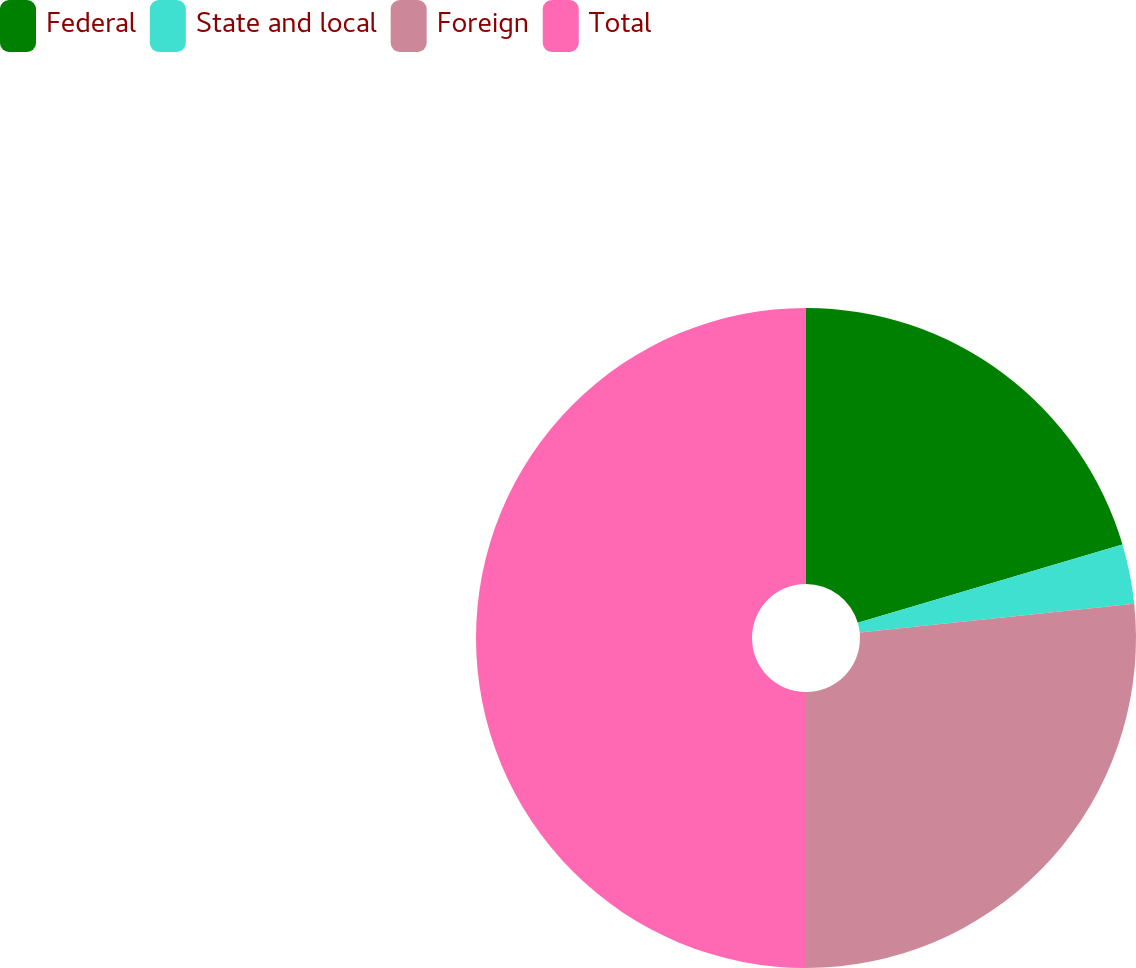<chart> <loc_0><loc_0><loc_500><loc_500><pie_chart><fcel>Federal<fcel>State and local<fcel>Foreign<fcel>Total<nl><fcel>20.43%<fcel>2.92%<fcel>26.65%<fcel>50.0%<nl></chart> 